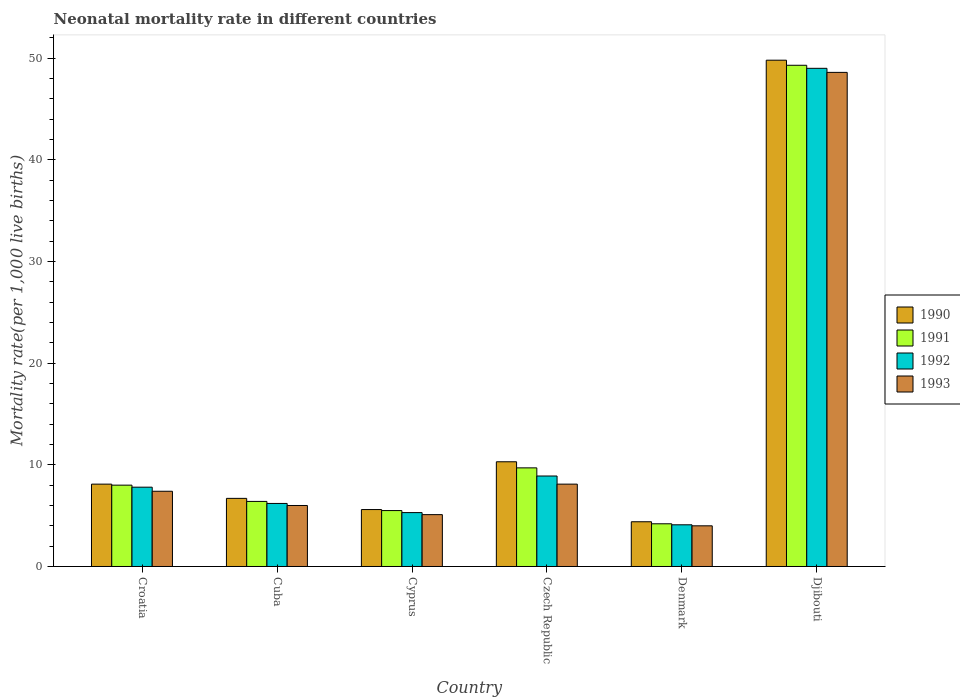How many groups of bars are there?
Offer a very short reply. 6. How many bars are there on the 2nd tick from the right?
Ensure brevity in your answer.  4. What is the label of the 2nd group of bars from the left?
Make the answer very short. Cuba. Across all countries, what is the maximum neonatal mortality rate in 1990?
Ensure brevity in your answer.  49.8. In which country was the neonatal mortality rate in 1993 maximum?
Offer a terse response. Djibouti. What is the total neonatal mortality rate in 1993 in the graph?
Offer a very short reply. 79.2. What is the difference between the neonatal mortality rate in 1992 in Cuba and that in Denmark?
Your response must be concise. 2.1. What is the average neonatal mortality rate in 1992 per country?
Offer a terse response. 13.55. What is the difference between the neonatal mortality rate of/in 1991 and neonatal mortality rate of/in 1990 in Czech Republic?
Keep it short and to the point. -0.6. What is the ratio of the neonatal mortality rate in 1990 in Czech Republic to that in Denmark?
Your answer should be very brief. 2.34. Is the neonatal mortality rate in 1993 in Cyprus less than that in Czech Republic?
Make the answer very short. Yes. Is the difference between the neonatal mortality rate in 1991 in Denmark and Djibouti greater than the difference between the neonatal mortality rate in 1990 in Denmark and Djibouti?
Give a very brief answer. Yes. What is the difference between the highest and the second highest neonatal mortality rate in 1990?
Keep it short and to the point. -41.7. What is the difference between the highest and the lowest neonatal mortality rate in 1992?
Make the answer very short. 44.9. In how many countries, is the neonatal mortality rate in 1993 greater than the average neonatal mortality rate in 1993 taken over all countries?
Provide a succinct answer. 1. What does the 4th bar from the right in Djibouti represents?
Your response must be concise. 1990. Is it the case that in every country, the sum of the neonatal mortality rate in 1992 and neonatal mortality rate in 1991 is greater than the neonatal mortality rate in 1990?
Ensure brevity in your answer.  Yes. How many bars are there?
Give a very brief answer. 24. What is the difference between two consecutive major ticks on the Y-axis?
Ensure brevity in your answer.  10. Are the values on the major ticks of Y-axis written in scientific E-notation?
Offer a very short reply. No. What is the title of the graph?
Your response must be concise. Neonatal mortality rate in different countries. What is the label or title of the Y-axis?
Provide a succinct answer. Mortality rate(per 1,0 live births). What is the Mortality rate(per 1,000 live births) in 1990 in Croatia?
Your answer should be compact. 8.1. What is the Mortality rate(per 1,000 live births) of 1991 in Croatia?
Keep it short and to the point. 8. What is the Mortality rate(per 1,000 live births) of 1990 in Cuba?
Your answer should be very brief. 6.7. What is the Mortality rate(per 1,000 live births) of 1992 in Cuba?
Offer a terse response. 6.2. What is the Mortality rate(per 1,000 live births) in 1991 in Cyprus?
Keep it short and to the point. 5.5. What is the Mortality rate(per 1,000 live births) in 1992 in Cyprus?
Offer a terse response. 5.3. What is the Mortality rate(per 1,000 live births) of 1993 in Cyprus?
Your answer should be very brief. 5.1. What is the Mortality rate(per 1,000 live births) in 1990 in Czech Republic?
Make the answer very short. 10.3. What is the Mortality rate(per 1,000 live births) of 1992 in Czech Republic?
Your answer should be very brief. 8.9. What is the Mortality rate(per 1,000 live births) in 1990 in Denmark?
Ensure brevity in your answer.  4.4. What is the Mortality rate(per 1,000 live births) in 1991 in Denmark?
Keep it short and to the point. 4.2. What is the Mortality rate(per 1,000 live births) of 1992 in Denmark?
Give a very brief answer. 4.1. What is the Mortality rate(per 1,000 live births) of 1993 in Denmark?
Make the answer very short. 4. What is the Mortality rate(per 1,000 live births) of 1990 in Djibouti?
Ensure brevity in your answer.  49.8. What is the Mortality rate(per 1,000 live births) of 1991 in Djibouti?
Provide a short and direct response. 49.3. What is the Mortality rate(per 1,000 live births) in 1992 in Djibouti?
Provide a short and direct response. 49. What is the Mortality rate(per 1,000 live births) in 1993 in Djibouti?
Keep it short and to the point. 48.6. Across all countries, what is the maximum Mortality rate(per 1,000 live births) in 1990?
Your response must be concise. 49.8. Across all countries, what is the maximum Mortality rate(per 1,000 live births) in 1991?
Provide a succinct answer. 49.3. Across all countries, what is the maximum Mortality rate(per 1,000 live births) of 1992?
Your answer should be compact. 49. Across all countries, what is the maximum Mortality rate(per 1,000 live births) of 1993?
Ensure brevity in your answer.  48.6. Across all countries, what is the minimum Mortality rate(per 1,000 live births) of 1990?
Your response must be concise. 4.4. Across all countries, what is the minimum Mortality rate(per 1,000 live births) of 1991?
Provide a short and direct response. 4.2. Across all countries, what is the minimum Mortality rate(per 1,000 live births) in 1992?
Keep it short and to the point. 4.1. Across all countries, what is the minimum Mortality rate(per 1,000 live births) of 1993?
Your response must be concise. 4. What is the total Mortality rate(per 1,000 live births) of 1990 in the graph?
Provide a short and direct response. 84.9. What is the total Mortality rate(per 1,000 live births) in 1991 in the graph?
Ensure brevity in your answer.  83.1. What is the total Mortality rate(per 1,000 live births) in 1992 in the graph?
Offer a terse response. 81.3. What is the total Mortality rate(per 1,000 live births) in 1993 in the graph?
Your answer should be very brief. 79.2. What is the difference between the Mortality rate(per 1,000 live births) of 1991 in Croatia and that in Cuba?
Keep it short and to the point. 1.6. What is the difference between the Mortality rate(per 1,000 live births) of 1992 in Croatia and that in Cuba?
Your response must be concise. 1.6. What is the difference between the Mortality rate(per 1,000 live births) of 1993 in Croatia and that in Cuba?
Your answer should be compact. 1.4. What is the difference between the Mortality rate(per 1,000 live births) in 1990 in Croatia and that in Cyprus?
Your response must be concise. 2.5. What is the difference between the Mortality rate(per 1,000 live births) in 1991 in Croatia and that in Cyprus?
Your answer should be compact. 2.5. What is the difference between the Mortality rate(per 1,000 live births) of 1990 in Croatia and that in Czech Republic?
Offer a terse response. -2.2. What is the difference between the Mortality rate(per 1,000 live births) in 1991 in Croatia and that in Czech Republic?
Offer a terse response. -1.7. What is the difference between the Mortality rate(per 1,000 live births) of 1993 in Croatia and that in Czech Republic?
Offer a very short reply. -0.7. What is the difference between the Mortality rate(per 1,000 live births) of 1990 in Croatia and that in Denmark?
Keep it short and to the point. 3.7. What is the difference between the Mortality rate(per 1,000 live births) in 1992 in Croatia and that in Denmark?
Make the answer very short. 3.7. What is the difference between the Mortality rate(per 1,000 live births) in 1990 in Croatia and that in Djibouti?
Your response must be concise. -41.7. What is the difference between the Mortality rate(per 1,000 live births) in 1991 in Croatia and that in Djibouti?
Give a very brief answer. -41.3. What is the difference between the Mortality rate(per 1,000 live births) in 1992 in Croatia and that in Djibouti?
Offer a terse response. -41.2. What is the difference between the Mortality rate(per 1,000 live births) of 1993 in Croatia and that in Djibouti?
Offer a very short reply. -41.2. What is the difference between the Mortality rate(per 1,000 live births) in 1993 in Cuba and that in Cyprus?
Your answer should be compact. 0.9. What is the difference between the Mortality rate(per 1,000 live births) in 1990 in Cuba and that in Czech Republic?
Your answer should be very brief. -3.6. What is the difference between the Mortality rate(per 1,000 live births) of 1992 in Cuba and that in Czech Republic?
Offer a terse response. -2.7. What is the difference between the Mortality rate(per 1,000 live births) in 1992 in Cuba and that in Denmark?
Provide a succinct answer. 2.1. What is the difference between the Mortality rate(per 1,000 live births) of 1993 in Cuba and that in Denmark?
Offer a very short reply. 2. What is the difference between the Mortality rate(per 1,000 live births) of 1990 in Cuba and that in Djibouti?
Provide a short and direct response. -43.1. What is the difference between the Mortality rate(per 1,000 live births) of 1991 in Cuba and that in Djibouti?
Provide a short and direct response. -42.9. What is the difference between the Mortality rate(per 1,000 live births) in 1992 in Cuba and that in Djibouti?
Provide a succinct answer. -42.8. What is the difference between the Mortality rate(per 1,000 live births) in 1993 in Cuba and that in Djibouti?
Your answer should be compact. -42.6. What is the difference between the Mortality rate(per 1,000 live births) of 1990 in Cyprus and that in Czech Republic?
Your answer should be very brief. -4.7. What is the difference between the Mortality rate(per 1,000 live births) in 1991 in Cyprus and that in Czech Republic?
Provide a succinct answer. -4.2. What is the difference between the Mortality rate(per 1,000 live births) in 1992 in Cyprus and that in Czech Republic?
Ensure brevity in your answer.  -3.6. What is the difference between the Mortality rate(per 1,000 live births) of 1993 in Cyprus and that in Czech Republic?
Give a very brief answer. -3. What is the difference between the Mortality rate(per 1,000 live births) of 1990 in Cyprus and that in Denmark?
Provide a short and direct response. 1.2. What is the difference between the Mortality rate(per 1,000 live births) of 1992 in Cyprus and that in Denmark?
Provide a short and direct response. 1.2. What is the difference between the Mortality rate(per 1,000 live births) in 1990 in Cyprus and that in Djibouti?
Provide a short and direct response. -44.2. What is the difference between the Mortality rate(per 1,000 live births) in 1991 in Cyprus and that in Djibouti?
Keep it short and to the point. -43.8. What is the difference between the Mortality rate(per 1,000 live births) in 1992 in Cyprus and that in Djibouti?
Give a very brief answer. -43.7. What is the difference between the Mortality rate(per 1,000 live births) in 1993 in Cyprus and that in Djibouti?
Your answer should be compact. -43.5. What is the difference between the Mortality rate(per 1,000 live births) in 1990 in Czech Republic and that in Denmark?
Make the answer very short. 5.9. What is the difference between the Mortality rate(per 1,000 live births) of 1991 in Czech Republic and that in Denmark?
Offer a very short reply. 5.5. What is the difference between the Mortality rate(per 1,000 live births) in 1992 in Czech Republic and that in Denmark?
Make the answer very short. 4.8. What is the difference between the Mortality rate(per 1,000 live births) of 1990 in Czech Republic and that in Djibouti?
Your response must be concise. -39.5. What is the difference between the Mortality rate(per 1,000 live births) in 1991 in Czech Republic and that in Djibouti?
Your answer should be very brief. -39.6. What is the difference between the Mortality rate(per 1,000 live births) of 1992 in Czech Republic and that in Djibouti?
Keep it short and to the point. -40.1. What is the difference between the Mortality rate(per 1,000 live births) in 1993 in Czech Republic and that in Djibouti?
Your response must be concise. -40.5. What is the difference between the Mortality rate(per 1,000 live births) in 1990 in Denmark and that in Djibouti?
Your answer should be very brief. -45.4. What is the difference between the Mortality rate(per 1,000 live births) of 1991 in Denmark and that in Djibouti?
Provide a short and direct response. -45.1. What is the difference between the Mortality rate(per 1,000 live births) of 1992 in Denmark and that in Djibouti?
Offer a very short reply. -44.9. What is the difference between the Mortality rate(per 1,000 live births) in 1993 in Denmark and that in Djibouti?
Offer a terse response. -44.6. What is the difference between the Mortality rate(per 1,000 live births) of 1990 in Croatia and the Mortality rate(per 1,000 live births) of 1992 in Cuba?
Offer a terse response. 1.9. What is the difference between the Mortality rate(per 1,000 live births) in 1992 in Croatia and the Mortality rate(per 1,000 live births) in 1993 in Cuba?
Give a very brief answer. 1.8. What is the difference between the Mortality rate(per 1,000 live births) of 1990 in Croatia and the Mortality rate(per 1,000 live births) of 1991 in Cyprus?
Your answer should be compact. 2.6. What is the difference between the Mortality rate(per 1,000 live births) in 1990 in Croatia and the Mortality rate(per 1,000 live births) in 1993 in Cyprus?
Offer a terse response. 3. What is the difference between the Mortality rate(per 1,000 live births) of 1991 in Croatia and the Mortality rate(per 1,000 live births) of 1992 in Cyprus?
Give a very brief answer. 2.7. What is the difference between the Mortality rate(per 1,000 live births) of 1992 in Croatia and the Mortality rate(per 1,000 live births) of 1993 in Cyprus?
Keep it short and to the point. 2.7. What is the difference between the Mortality rate(per 1,000 live births) in 1990 in Croatia and the Mortality rate(per 1,000 live births) in 1991 in Czech Republic?
Keep it short and to the point. -1.6. What is the difference between the Mortality rate(per 1,000 live births) of 1990 in Croatia and the Mortality rate(per 1,000 live births) of 1992 in Czech Republic?
Provide a succinct answer. -0.8. What is the difference between the Mortality rate(per 1,000 live births) in 1991 in Croatia and the Mortality rate(per 1,000 live births) in 1992 in Czech Republic?
Offer a terse response. -0.9. What is the difference between the Mortality rate(per 1,000 live births) of 1992 in Croatia and the Mortality rate(per 1,000 live births) of 1993 in Czech Republic?
Make the answer very short. -0.3. What is the difference between the Mortality rate(per 1,000 live births) in 1990 in Croatia and the Mortality rate(per 1,000 live births) in 1991 in Denmark?
Provide a short and direct response. 3.9. What is the difference between the Mortality rate(per 1,000 live births) in 1990 in Croatia and the Mortality rate(per 1,000 live births) in 1992 in Denmark?
Keep it short and to the point. 4. What is the difference between the Mortality rate(per 1,000 live births) of 1991 in Croatia and the Mortality rate(per 1,000 live births) of 1993 in Denmark?
Ensure brevity in your answer.  4. What is the difference between the Mortality rate(per 1,000 live births) of 1992 in Croatia and the Mortality rate(per 1,000 live births) of 1993 in Denmark?
Offer a very short reply. 3.8. What is the difference between the Mortality rate(per 1,000 live births) of 1990 in Croatia and the Mortality rate(per 1,000 live births) of 1991 in Djibouti?
Your answer should be very brief. -41.2. What is the difference between the Mortality rate(per 1,000 live births) of 1990 in Croatia and the Mortality rate(per 1,000 live births) of 1992 in Djibouti?
Provide a succinct answer. -40.9. What is the difference between the Mortality rate(per 1,000 live births) in 1990 in Croatia and the Mortality rate(per 1,000 live births) in 1993 in Djibouti?
Offer a terse response. -40.5. What is the difference between the Mortality rate(per 1,000 live births) in 1991 in Croatia and the Mortality rate(per 1,000 live births) in 1992 in Djibouti?
Keep it short and to the point. -41. What is the difference between the Mortality rate(per 1,000 live births) in 1991 in Croatia and the Mortality rate(per 1,000 live births) in 1993 in Djibouti?
Offer a terse response. -40.6. What is the difference between the Mortality rate(per 1,000 live births) of 1992 in Croatia and the Mortality rate(per 1,000 live births) of 1993 in Djibouti?
Offer a terse response. -40.8. What is the difference between the Mortality rate(per 1,000 live births) of 1990 in Cuba and the Mortality rate(per 1,000 live births) of 1992 in Cyprus?
Your response must be concise. 1.4. What is the difference between the Mortality rate(per 1,000 live births) of 1990 in Cuba and the Mortality rate(per 1,000 live births) of 1993 in Cyprus?
Make the answer very short. 1.6. What is the difference between the Mortality rate(per 1,000 live births) in 1991 in Cuba and the Mortality rate(per 1,000 live births) in 1992 in Cyprus?
Your answer should be very brief. 1.1. What is the difference between the Mortality rate(per 1,000 live births) in 1990 in Cuba and the Mortality rate(per 1,000 live births) in 1991 in Czech Republic?
Offer a very short reply. -3. What is the difference between the Mortality rate(per 1,000 live births) in 1991 in Cuba and the Mortality rate(per 1,000 live births) in 1992 in Czech Republic?
Give a very brief answer. -2.5. What is the difference between the Mortality rate(per 1,000 live births) of 1991 in Cuba and the Mortality rate(per 1,000 live births) of 1993 in Denmark?
Your response must be concise. 2.4. What is the difference between the Mortality rate(per 1,000 live births) of 1990 in Cuba and the Mortality rate(per 1,000 live births) of 1991 in Djibouti?
Make the answer very short. -42.6. What is the difference between the Mortality rate(per 1,000 live births) of 1990 in Cuba and the Mortality rate(per 1,000 live births) of 1992 in Djibouti?
Your response must be concise. -42.3. What is the difference between the Mortality rate(per 1,000 live births) of 1990 in Cuba and the Mortality rate(per 1,000 live births) of 1993 in Djibouti?
Your response must be concise. -41.9. What is the difference between the Mortality rate(per 1,000 live births) in 1991 in Cuba and the Mortality rate(per 1,000 live births) in 1992 in Djibouti?
Offer a very short reply. -42.6. What is the difference between the Mortality rate(per 1,000 live births) in 1991 in Cuba and the Mortality rate(per 1,000 live births) in 1993 in Djibouti?
Your answer should be very brief. -42.2. What is the difference between the Mortality rate(per 1,000 live births) of 1992 in Cuba and the Mortality rate(per 1,000 live births) of 1993 in Djibouti?
Offer a very short reply. -42.4. What is the difference between the Mortality rate(per 1,000 live births) in 1990 in Cyprus and the Mortality rate(per 1,000 live births) in 1991 in Czech Republic?
Offer a terse response. -4.1. What is the difference between the Mortality rate(per 1,000 live births) in 1991 in Cyprus and the Mortality rate(per 1,000 live births) in 1992 in Czech Republic?
Your answer should be compact. -3.4. What is the difference between the Mortality rate(per 1,000 live births) in 1991 in Cyprus and the Mortality rate(per 1,000 live births) in 1993 in Czech Republic?
Your response must be concise. -2.6. What is the difference between the Mortality rate(per 1,000 live births) in 1991 in Cyprus and the Mortality rate(per 1,000 live births) in 1992 in Denmark?
Provide a short and direct response. 1.4. What is the difference between the Mortality rate(per 1,000 live births) in 1990 in Cyprus and the Mortality rate(per 1,000 live births) in 1991 in Djibouti?
Ensure brevity in your answer.  -43.7. What is the difference between the Mortality rate(per 1,000 live births) of 1990 in Cyprus and the Mortality rate(per 1,000 live births) of 1992 in Djibouti?
Give a very brief answer. -43.4. What is the difference between the Mortality rate(per 1,000 live births) of 1990 in Cyprus and the Mortality rate(per 1,000 live births) of 1993 in Djibouti?
Offer a terse response. -43. What is the difference between the Mortality rate(per 1,000 live births) of 1991 in Cyprus and the Mortality rate(per 1,000 live births) of 1992 in Djibouti?
Offer a terse response. -43.5. What is the difference between the Mortality rate(per 1,000 live births) of 1991 in Cyprus and the Mortality rate(per 1,000 live births) of 1993 in Djibouti?
Your response must be concise. -43.1. What is the difference between the Mortality rate(per 1,000 live births) of 1992 in Cyprus and the Mortality rate(per 1,000 live births) of 1993 in Djibouti?
Give a very brief answer. -43.3. What is the difference between the Mortality rate(per 1,000 live births) of 1990 in Czech Republic and the Mortality rate(per 1,000 live births) of 1991 in Denmark?
Ensure brevity in your answer.  6.1. What is the difference between the Mortality rate(per 1,000 live births) of 1990 in Czech Republic and the Mortality rate(per 1,000 live births) of 1993 in Denmark?
Offer a terse response. 6.3. What is the difference between the Mortality rate(per 1,000 live births) of 1991 in Czech Republic and the Mortality rate(per 1,000 live births) of 1992 in Denmark?
Give a very brief answer. 5.6. What is the difference between the Mortality rate(per 1,000 live births) in 1992 in Czech Republic and the Mortality rate(per 1,000 live births) in 1993 in Denmark?
Ensure brevity in your answer.  4.9. What is the difference between the Mortality rate(per 1,000 live births) in 1990 in Czech Republic and the Mortality rate(per 1,000 live births) in 1991 in Djibouti?
Offer a very short reply. -39. What is the difference between the Mortality rate(per 1,000 live births) of 1990 in Czech Republic and the Mortality rate(per 1,000 live births) of 1992 in Djibouti?
Keep it short and to the point. -38.7. What is the difference between the Mortality rate(per 1,000 live births) in 1990 in Czech Republic and the Mortality rate(per 1,000 live births) in 1993 in Djibouti?
Provide a short and direct response. -38.3. What is the difference between the Mortality rate(per 1,000 live births) in 1991 in Czech Republic and the Mortality rate(per 1,000 live births) in 1992 in Djibouti?
Your answer should be very brief. -39.3. What is the difference between the Mortality rate(per 1,000 live births) of 1991 in Czech Republic and the Mortality rate(per 1,000 live births) of 1993 in Djibouti?
Give a very brief answer. -38.9. What is the difference between the Mortality rate(per 1,000 live births) in 1992 in Czech Republic and the Mortality rate(per 1,000 live births) in 1993 in Djibouti?
Your answer should be very brief. -39.7. What is the difference between the Mortality rate(per 1,000 live births) in 1990 in Denmark and the Mortality rate(per 1,000 live births) in 1991 in Djibouti?
Your answer should be compact. -44.9. What is the difference between the Mortality rate(per 1,000 live births) of 1990 in Denmark and the Mortality rate(per 1,000 live births) of 1992 in Djibouti?
Your response must be concise. -44.6. What is the difference between the Mortality rate(per 1,000 live births) of 1990 in Denmark and the Mortality rate(per 1,000 live births) of 1993 in Djibouti?
Keep it short and to the point. -44.2. What is the difference between the Mortality rate(per 1,000 live births) in 1991 in Denmark and the Mortality rate(per 1,000 live births) in 1992 in Djibouti?
Provide a short and direct response. -44.8. What is the difference between the Mortality rate(per 1,000 live births) of 1991 in Denmark and the Mortality rate(per 1,000 live births) of 1993 in Djibouti?
Ensure brevity in your answer.  -44.4. What is the difference between the Mortality rate(per 1,000 live births) of 1992 in Denmark and the Mortality rate(per 1,000 live births) of 1993 in Djibouti?
Provide a short and direct response. -44.5. What is the average Mortality rate(per 1,000 live births) in 1990 per country?
Provide a succinct answer. 14.15. What is the average Mortality rate(per 1,000 live births) of 1991 per country?
Provide a short and direct response. 13.85. What is the average Mortality rate(per 1,000 live births) of 1992 per country?
Provide a succinct answer. 13.55. What is the difference between the Mortality rate(per 1,000 live births) in 1990 and Mortality rate(per 1,000 live births) in 1992 in Croatia?
Provide a short and direct response. 0.3. What is the difference between the Mortality rate(per 1,000 live births) in 1991 and Mortality rate(per 1,000 live births) in 1993 in Croatia?
Your answer should be compact. 0.6. What is the difference between the Mortality rate(per 1,000 live births) of 1990 and Mortality rate(per 1,000 live births) of 1991 in Cuba?
Your response must be concise. 0.3. What is the difference between the Mortality rate(per 1,000 live births) in 1991 and Mortality rate(per 1,000 live births) in 1992 in Cuba?
Keep it short and to the point. 0.2. What is the difference between the Mortality rate(per 1,000 live births) in 1992 and Mortality rate(per 1,000 live births) in 1993 in Cuba?
Provide a succinct answer. 0.2. What is the difference between the Mortality rate(per 1,000 live births) in 1990 and Mortality rate(per 1,000 live births) in 1993 in Cyprus?
Make the answer very short. 0.5. What is the difference between the Mortality rate(per 1,000 live births) of 1991 and Mortality rate(per 1,000 live births) of 1992 in Cyprus?
Give a very brief answer. 0.2. What is the difference between the Mortality rate(per 1,000 live births) of 1991 and Mortality rate(per 1,000 live births) of 1993 in Cyprus?
Ensure brevity in your answer.  0.4. What is the difference between the Mortality rate(per 1,000 live births) in 1990 and Mortality rate(per 1,000 live births) in 1991 in Czech Republic?
Make the answer very short. 0.6. What is the difference between the Mortality rate(per 1,000 live births) of 1990 and Mortality rate(per 1,000 live births) of 1992 in Czech Republic?
Give a very brief answer. 1.4. What is the difference between the Mortality rate(per 1,000 live births) of 1990 and Mortality rate(per 1,000 live births) of 1993 in Czech Republic?
Give a very brief answer. 2.2. What is the difference between the Mortality rate(per 1,000 live births) in 1991 and Mortality rate(per 1,000 live births) in 1992 in Czech Republic?
Keep it short and to the point. 0.8. What is the difference between the Mortality rate(per 1,000 live births) in 1991 and Mortality rate(per 1,000 live births) in 1993 in Czech Republic?
Offer a terse response. 1.6. What is the difference between the Mortality rate(per 1,000 live births) in 1990 and Mortality rate(per 1,000 live births) in 1991 in Denmark?
Provide a succinct answer. 0.2. What is the difference between the Mortality rate(per 1,000 live births) in 1990 and Mortality rate(per 1,000 live births) in 1992 in Denmark?
Keep it short and to the point. 0.3. What is the difference between the Mortality rate(per 1,000 live births) of 1991 and Mortality rate(per 1,000 live births) of 1993 in Denmark?
Your answer should be compact. 0.2. What is the difference between the Mortality rate(per 1,000 live births) in 1990 and Mortality rate(per 1,000 live births) in 1991 in Djibouti?
Provide a short and direct response. 0.5. What is the difference between the Mortality rate(per 1,000 live births) of 1990 and Mortality rate(per 1,000 live births) of 1992 in Djibouti?
Provide a succinct answer. 0.8. What is the ratio of the Mortality rate(per 1,000 live births) of 1990 in Croatia to that in Cuba?
Your answer should be very brief. 1.21. What is the ratio of the Mortality rate(per 1,000 live births) of 1991 in Croatia to that in Cuba?
Provide a short and direct response. 1.25. What is the ratio of the Mortality rate(per 1,000 live births) in 1992 in Croatia to that in Cuba?
Make the answer very short. 1.26. What is the ratio of the Mortality rate(per 1,000 live births) of 1993 in Croatia to that in Cuba?
Your response must be concise. 1.23. What is the ratio of the Mortality rate(per 1,000 live births) in 1990 in Croatia to that in Cyprus?
Keep it short and to the point. 1.45. What is the ratio of the Mortality rate(per 1,000 live births) of 1991 in Croatia to that in Cyprus?
Offer a very short reply. 1.45. What is the ratio of the Mortality rate(per 1,000 live births) of 1992 in Croatia to that in Cyprus?
Your response must be concise. 1.47. What is the ratio of the Mortality rate(per 1,000 live births) in 1993 in Croatia to that in Cyprus?
Provide a succinct answer. 1.45. What is the ratio of the Mortality rate(per 1,000 live births) in 1990 in Croatia to that in Czech Republic?
Offer a terse response. 0.79. What is the ratio of the Mortality rate(per 1,000 live births) in 1991 in Croatia to that in Czech Republic?
Offer a terse response. 0.82. What is the ratio of the Mortality rate(per 1,000 live births) in 1992 in Croatia to that in Czech Republic?
Give a very brief answer. 0.88. What is the ratio of the Mortality rate(per 1,000 live births) of 1993 in Croatia to that in Czech Republic?
Provide a succinct answer. 0.91. What is the ratio of the Mortality rate(per 1,000 live births) of 1990 in Croatia to that in Denmark?
Provide a short and direct response. 1.84. What is the ratio of the Mortality rate(per 1,000 live births) of 1991 in Croatia to that in Denmark?
Provide a succinct answer. 1.9. What is the ratio of the Mortality rate(per 1,000 live births) in 1992 in Croatia to that in Denmark?
Your answer should be very brief. 1.9. What is the ratio of the Mortality rate(per 1,000 live births) of 1993 in Croatia to that in Denmark?
Provide a succinct answer. 1.85. What is the ratio of the Mortality rate(per 1,000 live births) in 1990 in Croatia to that in Djibouti?
Ensure brevity in your answer.  0.16. What is the ratio of the Mortality rate(per 1,000 live births) in 1991 in Croatia to that in Djibouti?
Offer a very short reply. 0.16. What is the ratio of the Mortality rate(per 1,000 live births) of 1992 in Croatia to that in Djibouti?
Offer a terse response. 0.16. What is the ratio of the Mortality rate(per 1,000 live births) of 1993 in Croatia to that in Djibouti?
Offer a terse response. 0.15. What is the ratio of the Mortality rate(per 1,000 live births) in 1990 in Cuba to that in Cyprus?
Provide a short and direct response. 1.2. What is the ratio of the Mortality rate(per 1,000 live births) in 1991 in Cuba to that in Cyprus?
Keep it short and to the point. 1.16. What is the ratio of the Mortality rate(per 1,000 live births) of 1992 in Cuba to that in Cyprus?
Your response must be concise. 1.17. What is the ratio of the Mortality rate(per 1,000 live births) of 1993 in Cuba to that in Cyprus?
Offer a terse response. 1.18. What is the ratio of the Mortality rate(per 1,000 live births) of 1990 in Cuba to that in Czech Republic?
Provide a succinct answer. 0.65. What is the ratio of the Mortality rate(per 1,000 live births) in 1991 in Cuba to that in Czech Republic?
Keep it short and to the point. 0.66. What is the ratio of the Mortality rate(per 1,000 live births) in 1992 in Cuba to that in Czech Republic?
Offer a terse response. 0.7. What is the ratio of the Mortality rate(per 1,000 live births) of 1993 in Cuba to that in Czech Republic?
Provide a succinct answer. 0.74. What is the ratio of the Mortality rate(per 1,000 live births) of 1990 in Cuba to that in Denmark?
Give a very brief answer. 1.52. What is the ratio of the Mortality rate(per 1,000 live births) in 1991 in Cuba to that in Denmark?
Your answer should be compact. 1.52. What is the ratio of the Mortality rate(per 1,000 live births) in 1992 in Cuba to that in Denmark?
Your answer should be very brief. 1.51. What is the ratio of the Mortality rate(per 1,000 live births) in 1990 in Cuba to that in Djibouti?
Offer a very short reply. 0.13. What is the ratio of the Mortality rate(per 1,000 live births) in 1991 in Cuba to that in Djibouti?
Keep it short and to the point. 0.13. What is the ratio of the Mortality rate(per 1,000 live births) of 1992 in Cuba to that in Djibouti?
Keep it short and to the point. 0.13. What is the ratio of the Mortality rate(per 1,000 live births) of 1993 in Cuba to that in Djibouti?
Your answer should be compact. 0.12. What is the ratio of the Mortality rate(per 1,000 live births) of 1990 in Cyprus to that in Czech Republic?
Offer a terse response. 0.54. What is the ratio of the Mortality rate(per 1,000 live births) of 1991 in Cyprus to that in Czech Republic?
Offer a very short reply. 0.57. What is the ratio of the Mortality rate(per 1,000 live births) of 1992 in Cyprus to that in Czech Republic?
Ensure brevity in your answer.  0.6. What is the ratio of the Mortality rate(per 1,000 live births) in 1993 in Cyprus to that in Czech Republic?
Provide a short and direct response. 0.63. What is the ratio of the Mortality rate(per 1,000 live births) in 1990 in Cyprus to that in Denmark?
Provide a short and direct response. 1.27. What is the ratio of the Mortality rate(per 1,000 live births) of 1991 in Cyprus to that in Denmark?
Offer a terse response. 1.31. What is the ratio of the Mortality rate(per 1,000 live births) of 1992 in Cyprus to that in Denmark?
Your answer should be compact. 1.29. What is the ratio of the Mortality rate(per 1,000 live births) of 1993 in Cyprus to that in Denmark?
Your answer should be very brief. 1.27. What is the ratio of the Mortality rate(per 1,000 live births) of 1990 in Cyprus to that in Djibouti?
Make the answer very short. 0.11. What is the ratio of the Mortality rate(per 1,000 live births) of 1991 in Cyprus to that in Djibouti?
Offer a very short reply. 0.11. What is the ratio of the Mortality rate(per 1,000 live births) in 1992 in Cyprus to that in Djibouti?
Ensure brevity in your answer.  0.11. What is the ratio of the Mortality rate(per 1,000 live births) of 1993 in Cyprus to that in Djibouti?
Make the answer very short. 0.1. What is the ratio of the Mortality rate(per 1,000 live births) of 1990 in Czech Republic to that in Denmark?
Provide a short and direct response. 2.34. What is the ratio of the Mortality rate(per 1,000 live births) in 1991 in Czech Republic to that in Denmark?
Offer a very short reply. 2.31. What is the ratio of the Mortality rate(per 1,000 live births) of 1992 in Czech Republic to that in Denmark?
Your answer should be compact. 2.17. What is the ratio of the Mortality rate(per 1,000 live births) of 1993 in Czech Republic to that in Denmark?
Offer a very short reply. 2.02. What is the ratio of the Mortality rate(per 1,000 live births) in 1990 in Czech Republic to that in Djibouti?
Offer a very short reply. 0.21. What is the ratio of the Mortality rate(per 1,000 live births) in 1991 in Czech Republic to that in Djibouti?
Make the answer very short. 0.2. What is the ratio of the Mortality rate(per 1,000 live births) of 1992 in Czech Republic to that in Djibouti?
Your answer should be very brief. 0.18. What is the ratio of the Mortality rate(per 1,000 live births) in 1993 in Czech Republic to that in Djibouti?
Your response must be concise. 0.17. What is the ratio of the Mortality rate(per 1,000 live births) of 1990 in Denmark to that in Djibouti?
Your answer should be very brief. 0.09. What is the ratio of the Mortality rate(per 1,000 live births) of 1991 in Denmark to that in Djibouti?
Your answer should be very brief. 0.09. What is the ratio of the Mortality rate(per 1,000 live births) in 1992 in Denmark to that in Djibouti?
Offer a very short reply. 0.08. What is the ratio of the Mortality rate(per 1,000 live births) in 1993 in Denmark to that in Djibouti?
Ensure brevity in your answer.  0.08. What is the difference between the highest and the second highest Mortality rate(per 1,000 live births) in 1990?
Provide a succinct answer. 39.5. What is the difference between the highest and the second highest Mortality rate(per 1,000 live births) in 1991?
Provide a succinct answer. 39.6. What is the difference between the highest and the second highest Mortality rate(per 1,000 live births) in 1992?
Ensure brevity in your answer.  40.1. What is the difference between the highest and the second highest Mortality rate(per 1,000 live births) in 1993?
Your answer should be compact. 40.5. What is the difference between the highest and the lowest Mortality rate(per 1,000 live births) of 1990?
Your answer should be compact. 45.4. What is the difference between the highest and the lowest Mortality rate(per 1,000 live births) of 1991?
Provide a short and direct response. 45.1. What is the difference between the highest and the lowest Mortality rate(per 1,000 live births) of 1992?
Provide a succinct answer. 44.9. What is the difference between the highest and the lowest Mortality rate(per 1,000 live births) in 1993?
Offer a terse response. 44.6. 